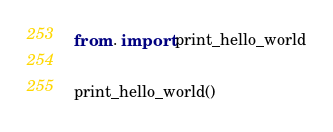<code> <loc_0><loc_0><loc_500><loc_500><_Python_>from . import print_hello_world

print_hello_world()
</code> 